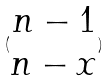Convert formula to latex. <formula><loc_0><loc_0><loc_500><loc_500>( \begin{matrix} n - 1 \\ n - x \end{matrix} )</formula> 